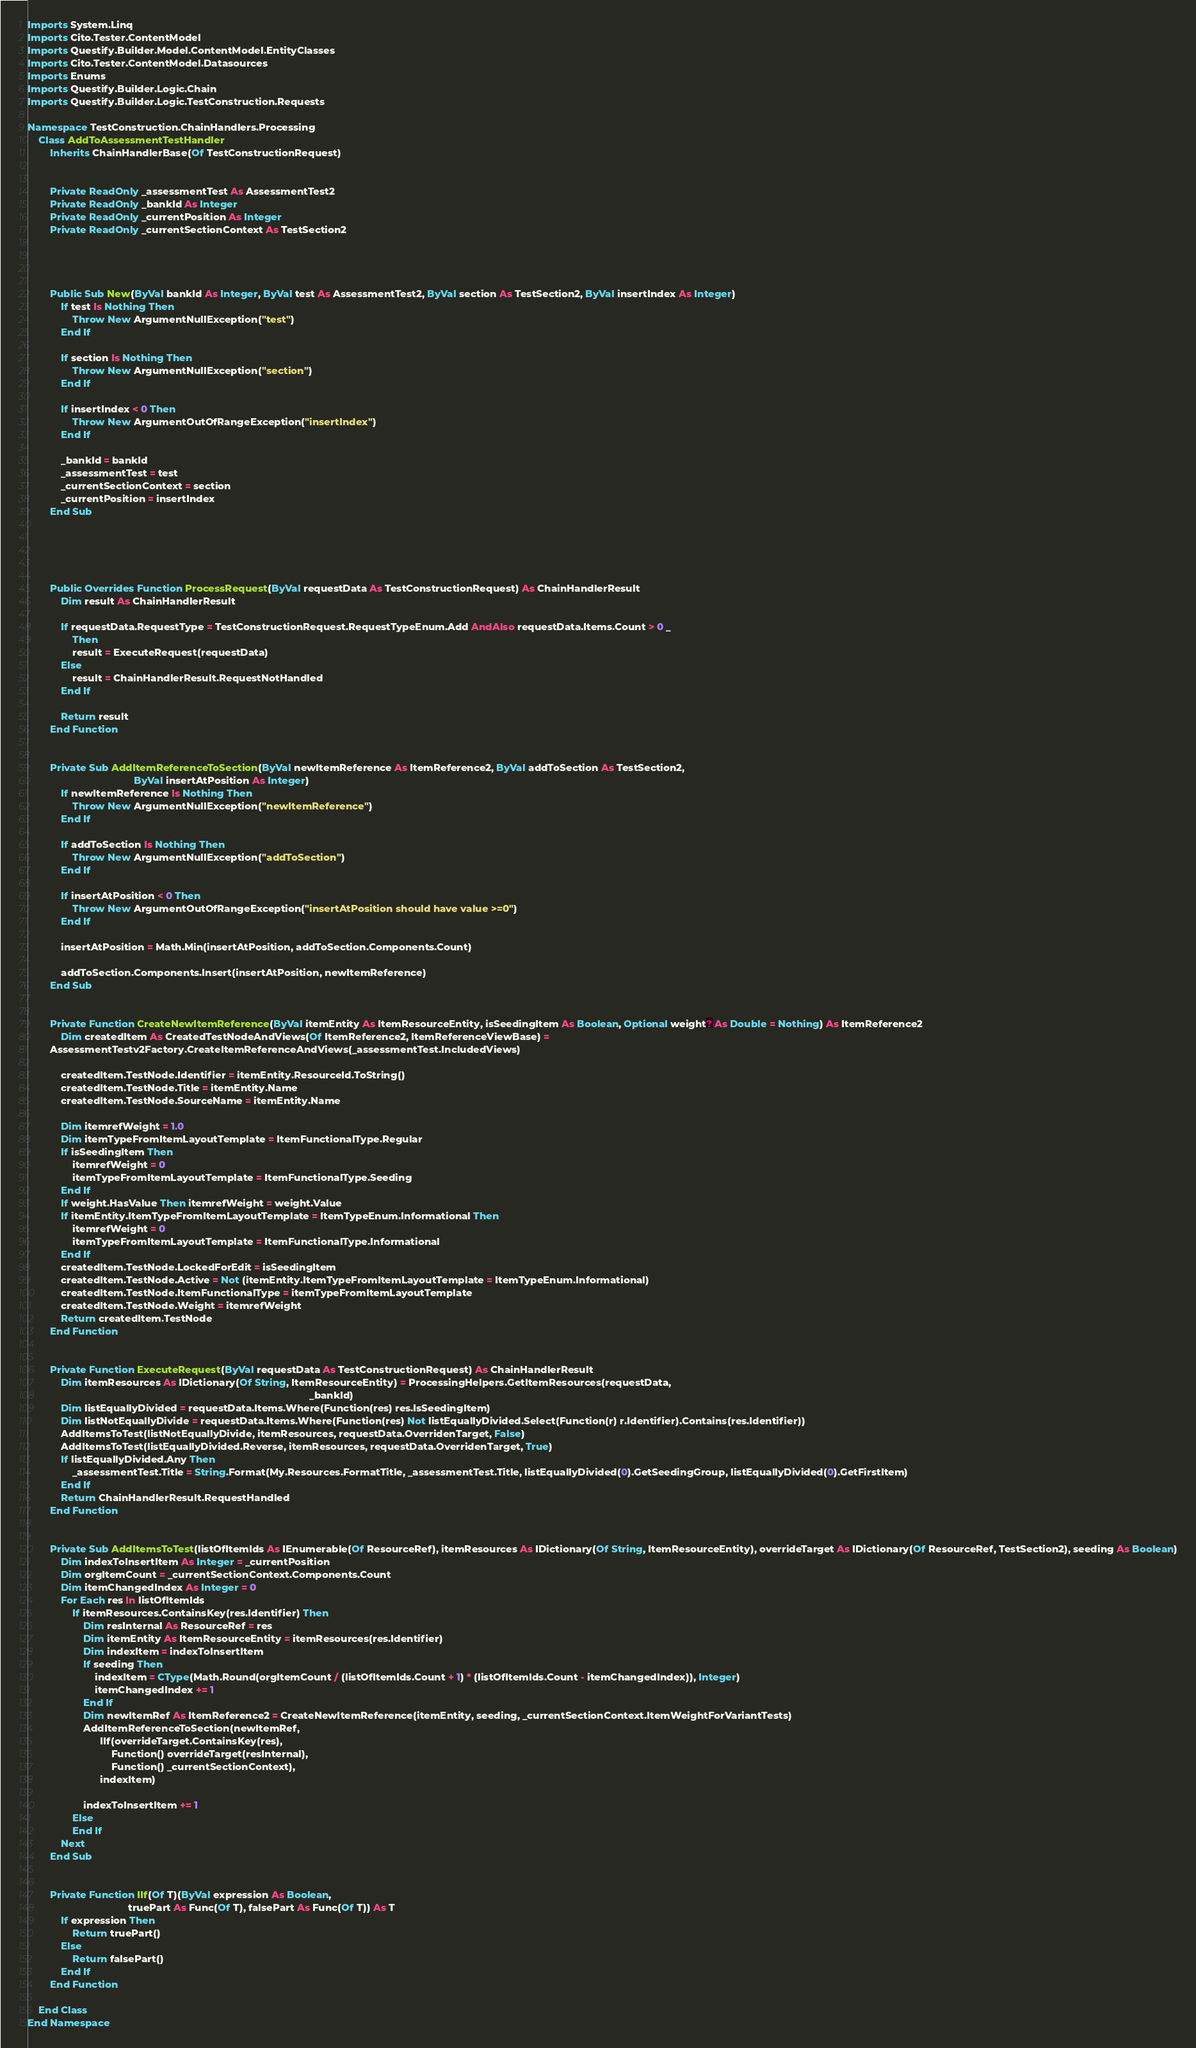Convert code to text. <code><loc_0><loc_0><loc_500><loc_500><_VisualBasic_>Imports System.Linq
Imports Cito.Tester.ContentModel
Imports Questify.Builder.Model.ContentModel.EntityClasses
Imports Cito.Tester.ContentModel.Datasources
Imports Enums
Imports Questify.Builder.Logic.Chain
Imports Questify.Builder.Logic.TestConstruction.Requests

Namespace TestConstruction.ChainHandlers.Processing
    Class AddToAssessmentTestHandler
        Inherits ChainHandlerBase(Of TestConstructionRequest)


        Private ReadOnly _assessmentTest As AssessmentTest2
        Private ReadOnly _bankId As Integer
        Private ReadOnly _currentPosition As Integer
        Private ReadOnly _currentSectionContext As TestSection2




        Public Sub New(ByVal bankId As Integer, ByVal test As AssessmentTest2, ByVal section As TestSection2, ByVal insertIndex As Integer)
            If test Is Nothing Then
                Throw New ArgumentNullException("test")
            End If

            If section Is Nothing Then
                Throw New ArgumentNullException("section")
            End If

            If insertIndex < 0 Then
                Throw New ArgumentOutOfRangeException("insertIndex")
            End If

            _bankId = bankId
            _assessmentTest = test
            _currentSectionContext = section
            _currentPosition = insertIndex
        End Sub





        Public Overrides Function ProcessRequest(ByVal requestData As TestConstructionRequest) As ChainHandlerResult
            Dim result As ChainHandlerResult

            If requestData.RequestType = TestConstructionRequest.RequestTypeEnum.Add AndAlso requestData.Items.Count > 0 _
                Then
                result = ExecuteRequest(requestData)
            Else
                result = ChainHandlerResult.RequestNotHandled
            End If

            Return result
        End Function


        Private Sub AddItemReferenceToSection(ByVal newItemReference As ItemReference2, ByVal addToSection As TestSection2,
                                      ByVal insertAtPosition As Integer)
            If newItemReference Is Nothing Then
                Throw New ArgumentNullException("newItemReference")
            End If

            If addToSection Is Nothing Then
                Throw New ArgumentNullException("addToSection")
            End If

            If insertAtPosition < 0 Then
                Throw New ArgumentOutOfRangeException("insertAtPosition should have value >=0")
            End If

            insertAtPosition = Math.Min(insertAtPosition, addToSection.Components.Count)

            addToSection.Components.Insert(insertAtPosition, newItemReference)
        End Sub


        Private Function CreateNewItemReference(ByVal itemEntity As ItemResourceEntity, isSeedingItem As Boolean, Optional weight? As Double = Nothing) As ItemReference2
            Dim createdItem As CreatedTestNodeAndViews(Of ItemReference2, ItemReferenceViewBase) =
        AssessmentTestv2Factory.CreateItemReferenceAndViews(_assessmentTest.IncludedViews)

            createdItem.TestNode.Identifier = itemEntity.ResourceId.ToString()
            createdItem.TestNode.Title = itemEntity.Name
            createdItem.TestNode.SourceName = itemEntity.Name

            Dim itemrefWeight = 1.0
            Dim itemTypeFromItemLayoutTemplate = ItemFunctionalType.Regular
            If isSeedingItem Then
                itemrefWeight = 0
                itemTypeFromItemLayoutTemplate = ItemFunctionalType.Seeding
            End If
            If weight.HasValue Then itemrefWeight = weight.Value
            If itemEntity.ItemTypeFromItemLayoutTemplate = ItemTypeEnum.Informational Then
                itemrefWeight = 0
                itemTypeFromItemLayoutTemplate = ItemFunctionalType.Informational
            End If
            createdItem.TestNode.LockedForEdit = isSeedingItem
            createdItem.TestNode.Active = Not (itemEntity.ItemTypeFromItemLayoutTemplate = ItemTypeEnum.Informational)
            createdItem.TestNode.ItemFunctionalType = itemTypeFromItemLayoutTemplate
            createdItem.TestNode.Weight = itemrefWeight
            Return createdItem.TestNode
        End Function


        Private Function ExecuteRequest(ByVal requestData As TestConstructionRequest) As ChainHandlerResult
            Dim itemResources As IDictionary(Of String, ItemResourceEntity) = ProcessingHelpers.GetItemResources(requestData,
                                                                                                     _bankId)
            Dim listEquallyDivided = requestData.Items.Where(Function(res) res.IsSeedingItem)
            Dim listNotEquallyDivide = requestData.Items.Where(Function(res) Not listEquallyDivided.Select(Function(r) r.Identifier).Contains(res.Identifier))
            AddItemsToTest(listNotEquallyDivide, itemResources, requestData.OverridenTarget, False)
            AddItemsToTest(listEquallyDivided.Reverse, itemResources, requestData.OverridenTarget, True)
            If listEquallyDivided.Any Then
                _assessmentTest.Title = String.Format(My.Resources.FormatTitle, _assessmentTest.Title, listEquallyDivided(0).GetSeedingGroup, listEquallyDivided(0).GetFirstItem)
            End If
            Return ChainHandlerResult.RequestHandled
        End Function


        Private Sub AddItemsToTest(listOfItemIds As IEnumerable(Of ResourceRef), itemResources As IDictionary(Of String, ItemResourceEntity), overrideTarget As IDictionary(Of ResourceRef, TestSection2), seeding As Boolean)
            Dim indexToInsertItem As Integer = _currentPosition
            Dim orgItemCount = _currentSectionContext.Components.Count
            Dim itemChangedIndex As Integer = 0
            For Each res In listOfItemIds
                If itemResources.ContainsKey(res.Identifier) Then
                    Dim resInternal As ResourceRef = res
                    Dim itemEntity As ItemResourceEntity = itemResources(res.Identifier)
                    Dim indexItem = indexToInsertItem
                    If seeding Then
                        indexItem = CType(Math.Round(orgItemCount / (listOfItemIds.Count + 1) * (listOfItemIds.Count - itemChangedIndex)), Integer)
                        itemChangedIndex += 1
                    End If
                    Dim newItemRef As ItemReference2 = CreateNewItemReference(itemEntity, seeding, _currentSectionContext.ItemWeightForVariantTests)
                    AddItemReferenceToSection(newItemRef,
                          IIf(overrideTarget.ContainsKey(res),
                              Function() overrideTarget(resInternal),
                              Function() _currentSectionContext),
                          indexItem)

                    indexToInsertItem += 1
                Else
                End If
            Next
        End Sub


        Private Function IIf(Of T)(ByVal expression As Boolean,
                                    truePart As Func(Of T), falsePart As Func(Of T)) As T
            If expression Then
                Return truePart()
            Else
                Return falsePart()
            End If
        End Function

    End Class
End Namespace</code> 